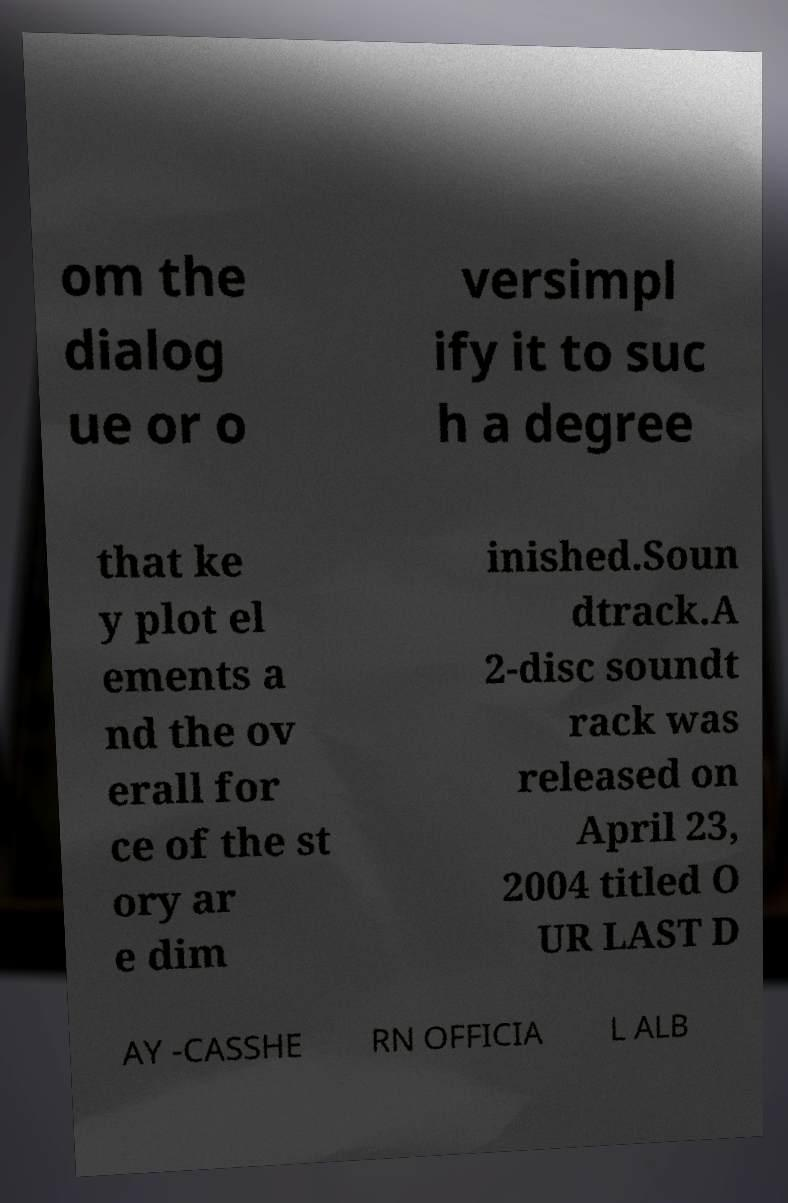Could you extract and type out the text from this image? om the dialog ue or o versimpl ify it to suc h a degree that ke y plot el ements a nd the ov erall for ce of the st ory ar e dim inished.Soun dtrack.A 2-disc soundt rack was released on April 23, 2004 titled O UR LAST D AY -CASSHE RN OFFICIA L ALB 